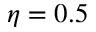Convert formula to latex. <formula><loc_0><loc_0><loc_500><loc_500>\eta = 0 . 5</formula> 